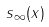<formula> <loc_0><loc_0><loc_500><loc_500>s _ { \infty } ( x )</formula> 